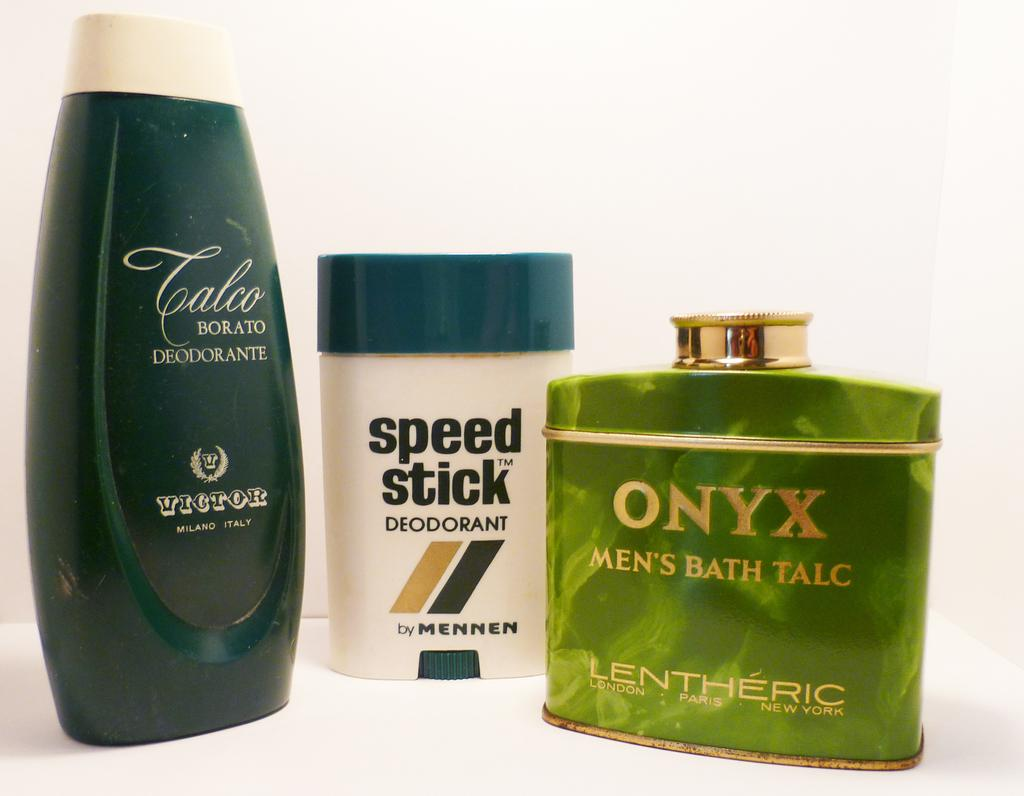<image>
Offer a succinct explanation of the picture presented. Some men's toiletries together on a counter including a speed stick. 